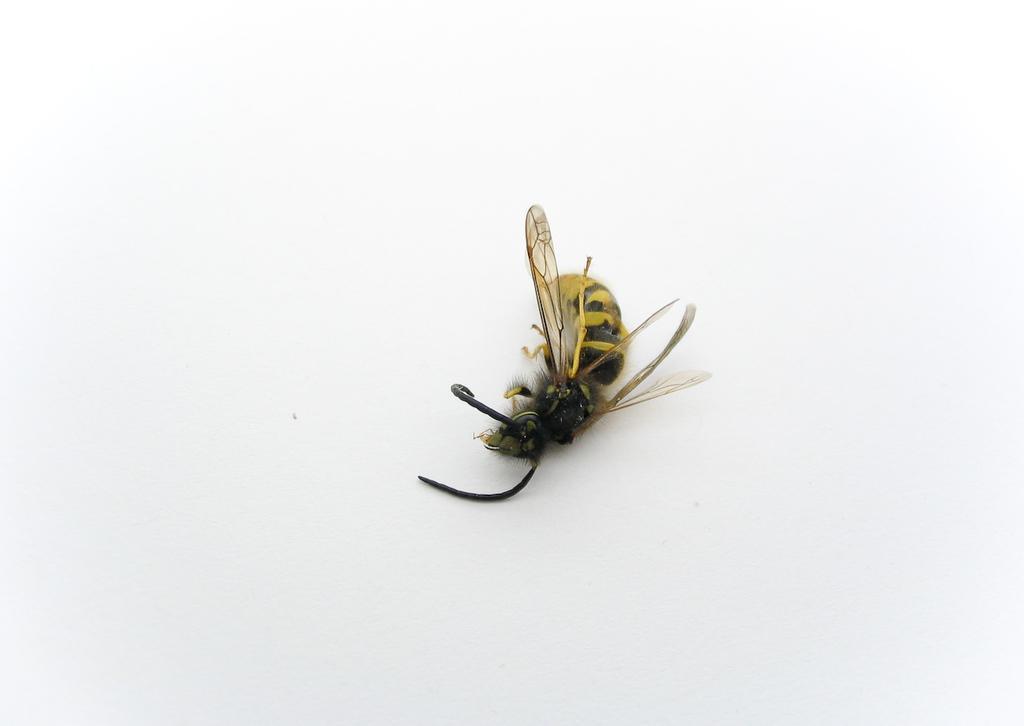How would you summarize this image in a sentence or two? This is the picture of a bee which is on the white background. 